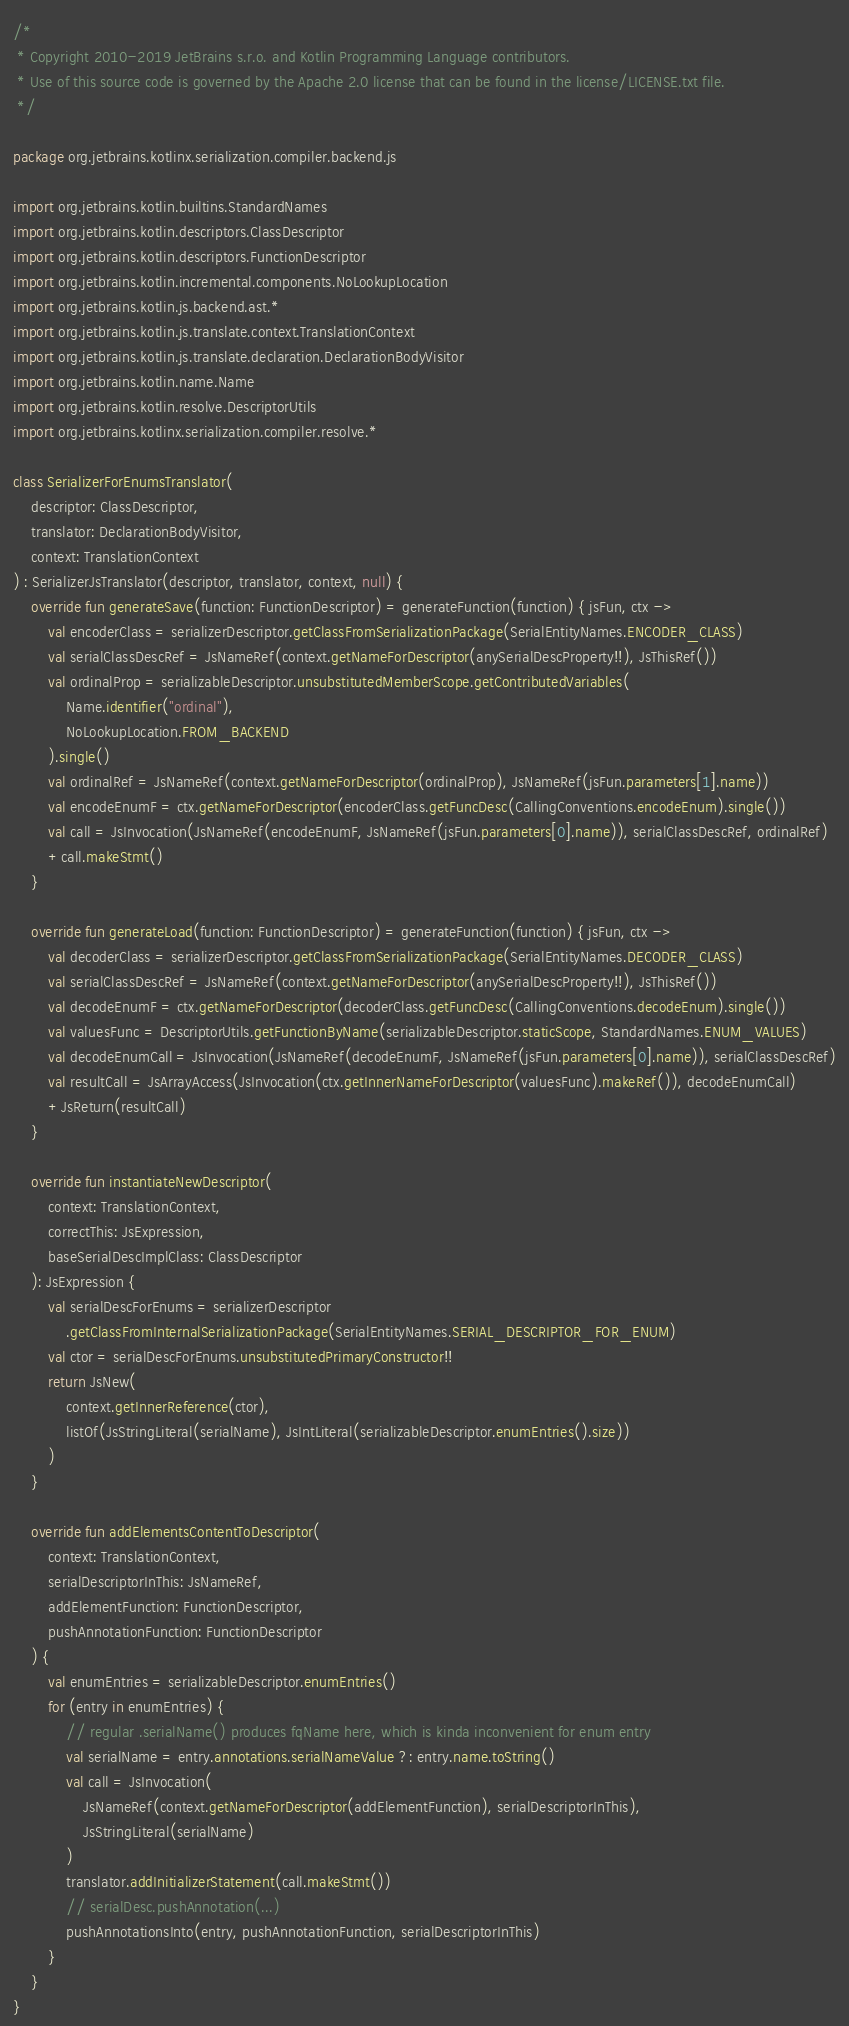Convert code to text. <code><loc_0><loc_0><loc_500><loc_500><_Kotlin_>/*
 * Copyright 2010-2019 JetBrains s.r.o. and Kotlin Programming Language contributors.
 * Use of this source code is governed by the Apache 2.0 license that can be found in the license/LICENSE.txt file.
 */

package org.jetbrains.kotlinx.serialization.compiler.backend.js

import org.jetbrains.kotlin.builtins.StandardNames
import org.jetbrains.kotlin.descriptors.ClassDescriptor
import org.jetbrains.kotlin.descriptors.FunctionDescriptor
import org.jetbrains.kotlin.incremental.components.NoLookupLocation
import org.jetbrains.kotlin.js.backend.ast.*
import org.jetbrains.kotlin.js.translate.context.TranslationContext
import org.jetbrains.kotlin.js.translate.declaration.DeclarationBodyVisitor
import org.jetbrains.kotlin.name.Name
import org.jetbrains.kotlin.resolve.DescriptorUtils
import org.jetbrains.kotlinx.serialization.compiler.resolve.*

class SerializerForEnumsTranslator(
    descriptor: ClassDescriptor,
    translator: DeclarationBodyVisitor,
    context: TranslationContext
) : SerializerJsTranslator(descriptor, translator, context, null) {
    override fun generateSave(function: FunctionDescriptor) = generateFunction(function) { jsFun, ctx ->
        val encoderClass = serializerDescriptor.getClassFromSerializationPackage(SerialEntityNames.ENCODER_CLASS)
        val serialClassDescRef = JsNameRef(context.getNameForDescriptor(anySerialDescProperty!!), JsThisRef())
        val ordinalProp = serializableDescriptor.unsubstitutedMemberScope.getContributedVariables(
            Name.identifier("ordinal"),
            NoLookupLocation.FROM_BACKEND
        ).single()
        val ordinalRef = JsNameRef(context.getNameForDescriptor(ordinalProp), JsNameRef(jsFun.parameters[1].name))
        val encodeEnumF = ctx.getNameForDescriptor(encoderClass.getFuncDesc(CallingConventions.encodeEnum).single())
        val call = JsInvocation(JsNameRef(encodeEnumF, JsNameRef(jsFun.parameters[0].name)), serialClassDescRef, ordinalRef)
        +call.makeStmt()
    }

    override fun generateLoad(function: FunctionDescriptor) = generateFunction(function) { jsFun, ctx ->
        val decoderClass = serializerDescriptor.getClassFromSerializationPackage(SerialEntityNames.DECODER_CLASS)
        val serialClassDescRef = JsNameRef(context.getNameForDescriptor(anySerialDescProperty!!), JsThisRef())
        val decodeEnumF = ctx.getNameForDescriptor(decoderClass.getFuncDesc(CallingConventions.decodeEnum).single())
        val valuesFunc = DescriptorUtils.getFunctionByName(serializableDescriptor.staticScope, StandardNames.ENUM_VALUES)
        val decodeEnumCall = JsInvocation(JsNameRef(decodeEnumF, JsNameRef(jsFun.parameters[0].name)), serialClassDescRef)
        val resultCall = JsArrayAccess(JsInvocation(ctx.getInnerNameForDescriptor(valuesFunc).makeRef()), decodeEnumCall)
        +JsReturn(resultCall)
    }

    override fun instantiateNewDescriptor(
        context: TranslationContext,
        correctThis: JsExpression,
        baseSerialDescImplClass: ClassDescriptor
    ): JsExpression {
        val serialDescForEnums = serializerDescriptor
            .getClassFromInternalSerializationPackage(SerialEntityNames.SERIAL_DESCRIPTOR_FOR_ENUM)
        val ctor = serialDescForEnums.unsubstitutedPrimaryConstructor!!
        return JsNew(
            context.getInnerReference(ctor),
            listOf(JsStringLiteral(serialName), JsIntLiteral(serializableDescriptor.enumEntries().size))
        )
    }

    override fun addElementsContentToDescriptor(
        context: TranslationContext,
        serialDescriptorInThis: JsNameRef,
        addElementFunction: FunctionDescriptor,
        pushAnnotationFunction: FunctionDescriptor
    ) {
        val enumEntries = serializableDescriptor.enumEntries()
        for (entry in enumEntries) {
            // regular .serialName() produces fqName here, which is kinda inconvenient for enum entry
            val serialName = entry.annotations.serialNameValue ?: entry.name.toString()
            val call = JsInvocation(
                JsNameRef(context.getNameForDescriptor(addElementFunction), serialDescriptorInThis),
                JsStringLiteral(serialName)
            )
            translator.addInitializerStatement(call.makeStmt())
            // serialDesc.pushAnnotation(...)
            pushAnnotationsInto(entry, pushAnnotationFunction, serialDescriptorInThis)
        }
    }
}
</code> 